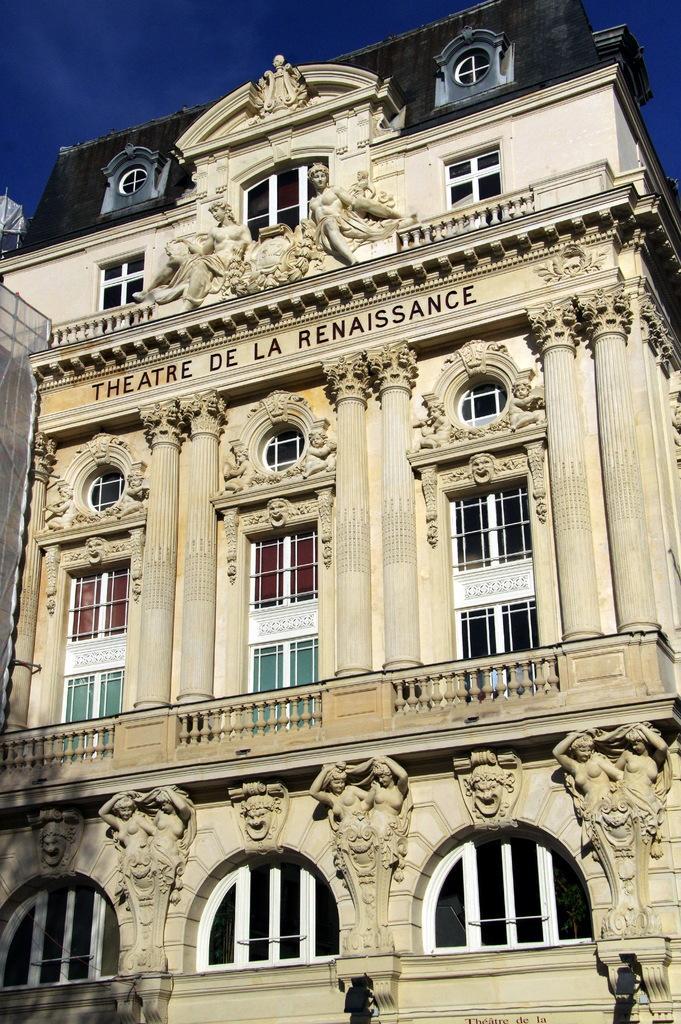How would you summarize this image in a sentence or two? In this picture we can see a building with windows and sculptures and behind the building there is a sky. 